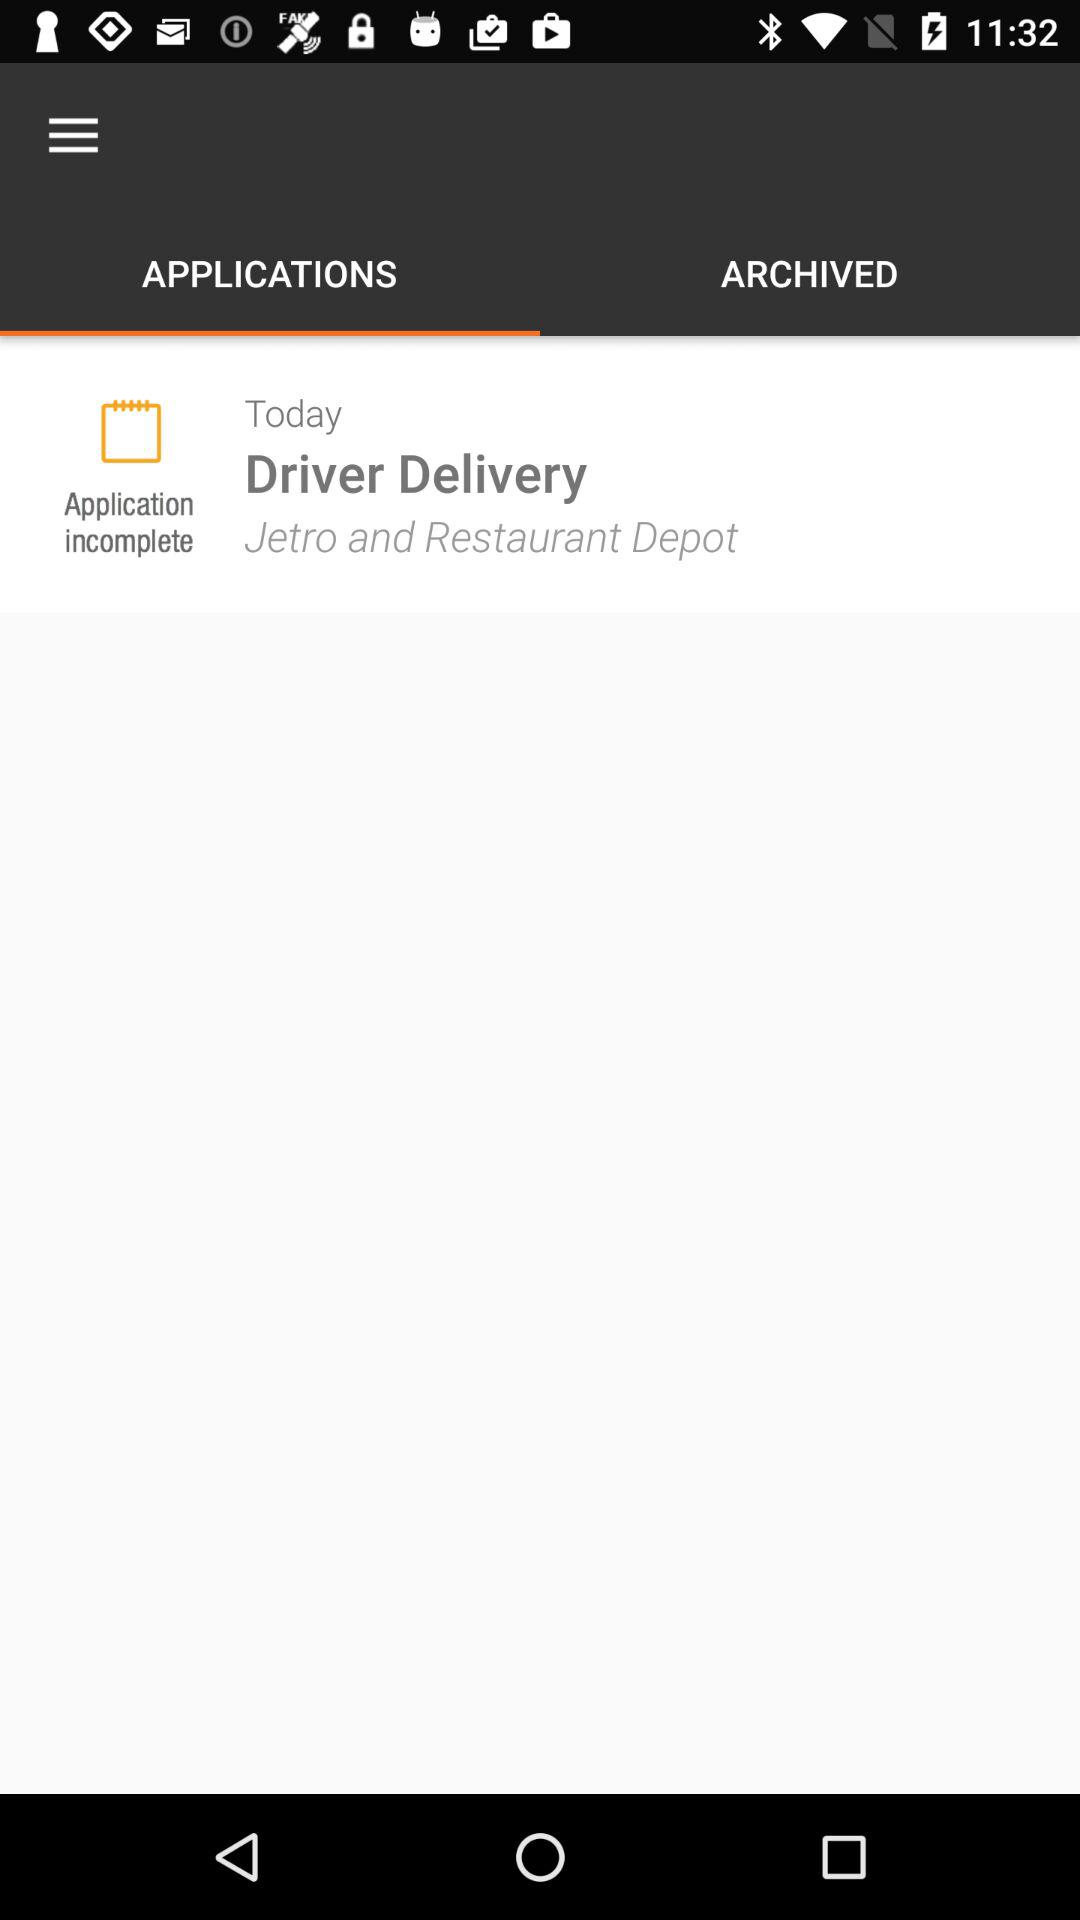Which tab is selected right now? The tab that is selected right now is "APPLICATIONS". 